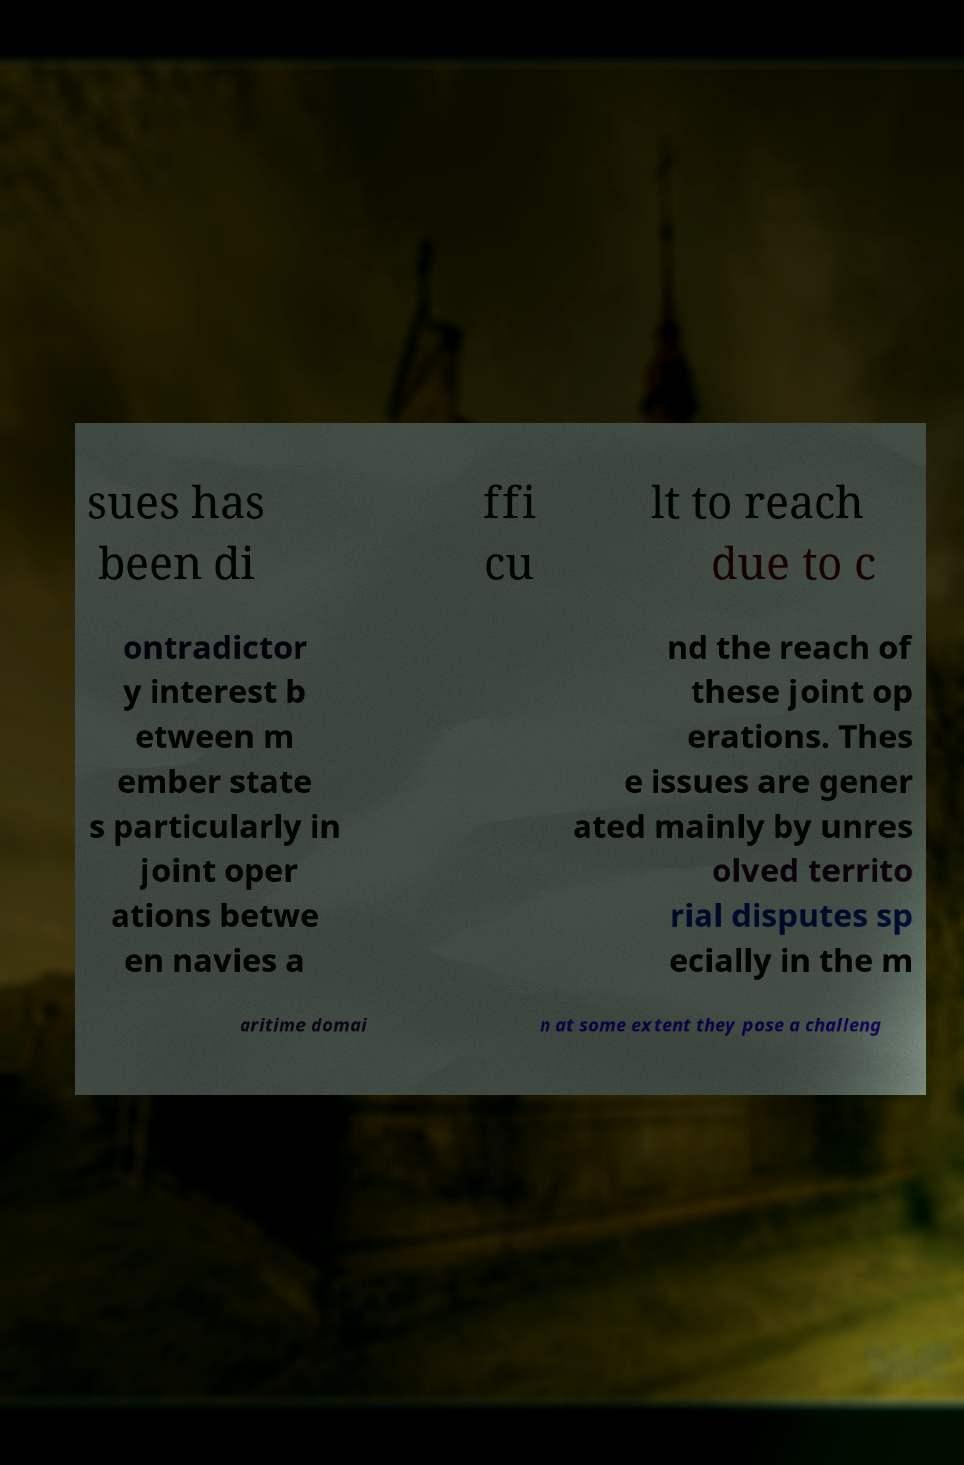For documentation purposes, I need the text within this image transcribed. Could you provide that? sues has been di ffi cu lt to reach due to c ontradictor y interest b etween m ember state s particularly in joint oper ations betwe en navies a nd the reach of these joint op erations. Thes e issues are gener ated mainly by unres olved territo rial disputes sp ecially in the m aritime domai n at some extent they pose a challeng 